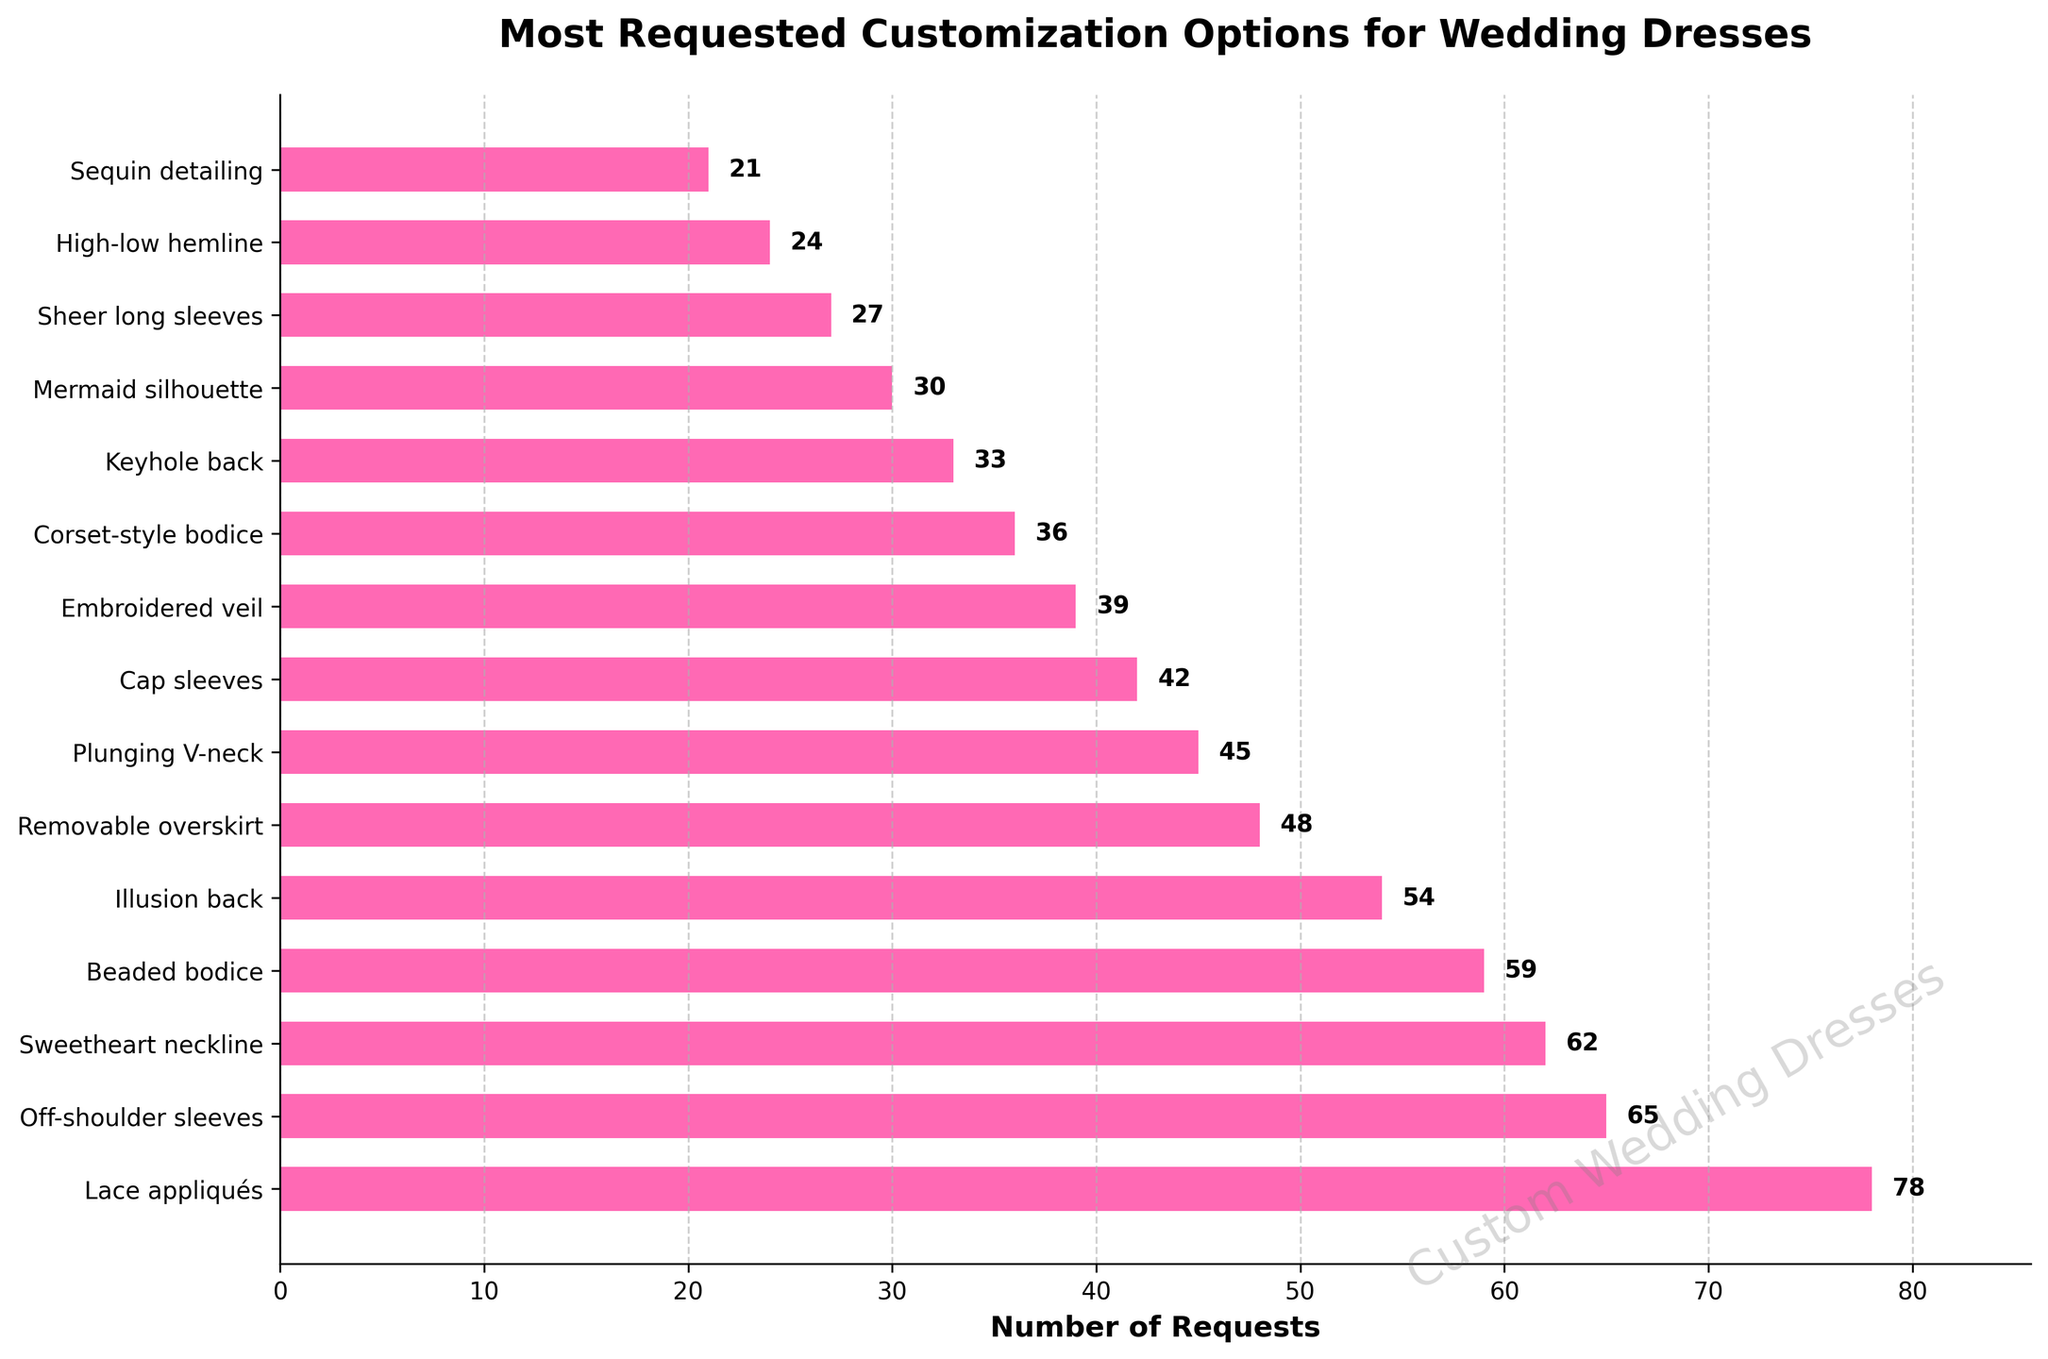What is the most requested customization option? The figure shows the number of requests for each customization option, and the bar for "Lace appliqués" extends the farthest.
Answer: Lace appliqués Which customization option has slightly fewer requests than "Beaded bodice"? From the figure, "Illusion back" has slightly fewer requests than "Beaded bodice".
Answer: Illusion back How many more requests does "Off-shoulder sleeves" have compared to "Plunging V-neck"? According to the figure, "Off-shoulder sleeves" has 65 requests and "Plunging V-neck" has 45 requests. The difference is 65 - 45 = 20.
Answer: 20 What is the sum of requests for "Sweetheart neckline", "Cap sleeves", and "Sequin detailing"? The requests are 62 for "Sweetheart neckline", 42 for "Cap sleeves", and 21 for "Sequin detailing". Summing these gives 62 + 42 + 21 = 125.
Answer: 125 Compare the number of requests for "Mermaid silhouette" and "Sheer long sleeves". Which one is requested more and by how much? "Mermaid silhouette" has 30 requests, and "Sheer long sleeves" has 27. "Mermaid silhouette" is requested 30 - 27 = 3 more times than "Sheer long sleeves".
Answer: Mermaid silhouette, 3 What is the average number of requests for the customization options listed? Adding up all the requests (78 + 65 + 62 + 59 + 54 + 48 + 45 + 42 + 39 + 36 + 33 + 30 + 27 + 24 + 21) equals 663. There are 15 options, so the average is 663 / 15 ≈ 44.2.
Answer: 44.2 Which customization option is third in terms of the highest number of requests? The third longest bar in the figure represents the "Sweetheart neckline" with 62 requests.
Answer: Sweetheart neckline What is the ratio of requests for "Embroidered veil" to "High-low hemline"? "Embroidered veil" has 39 requests, and "High-low hemline" has 24 requests. The ratio is 39 / 24 = 1.625.
Answer: 1.625 